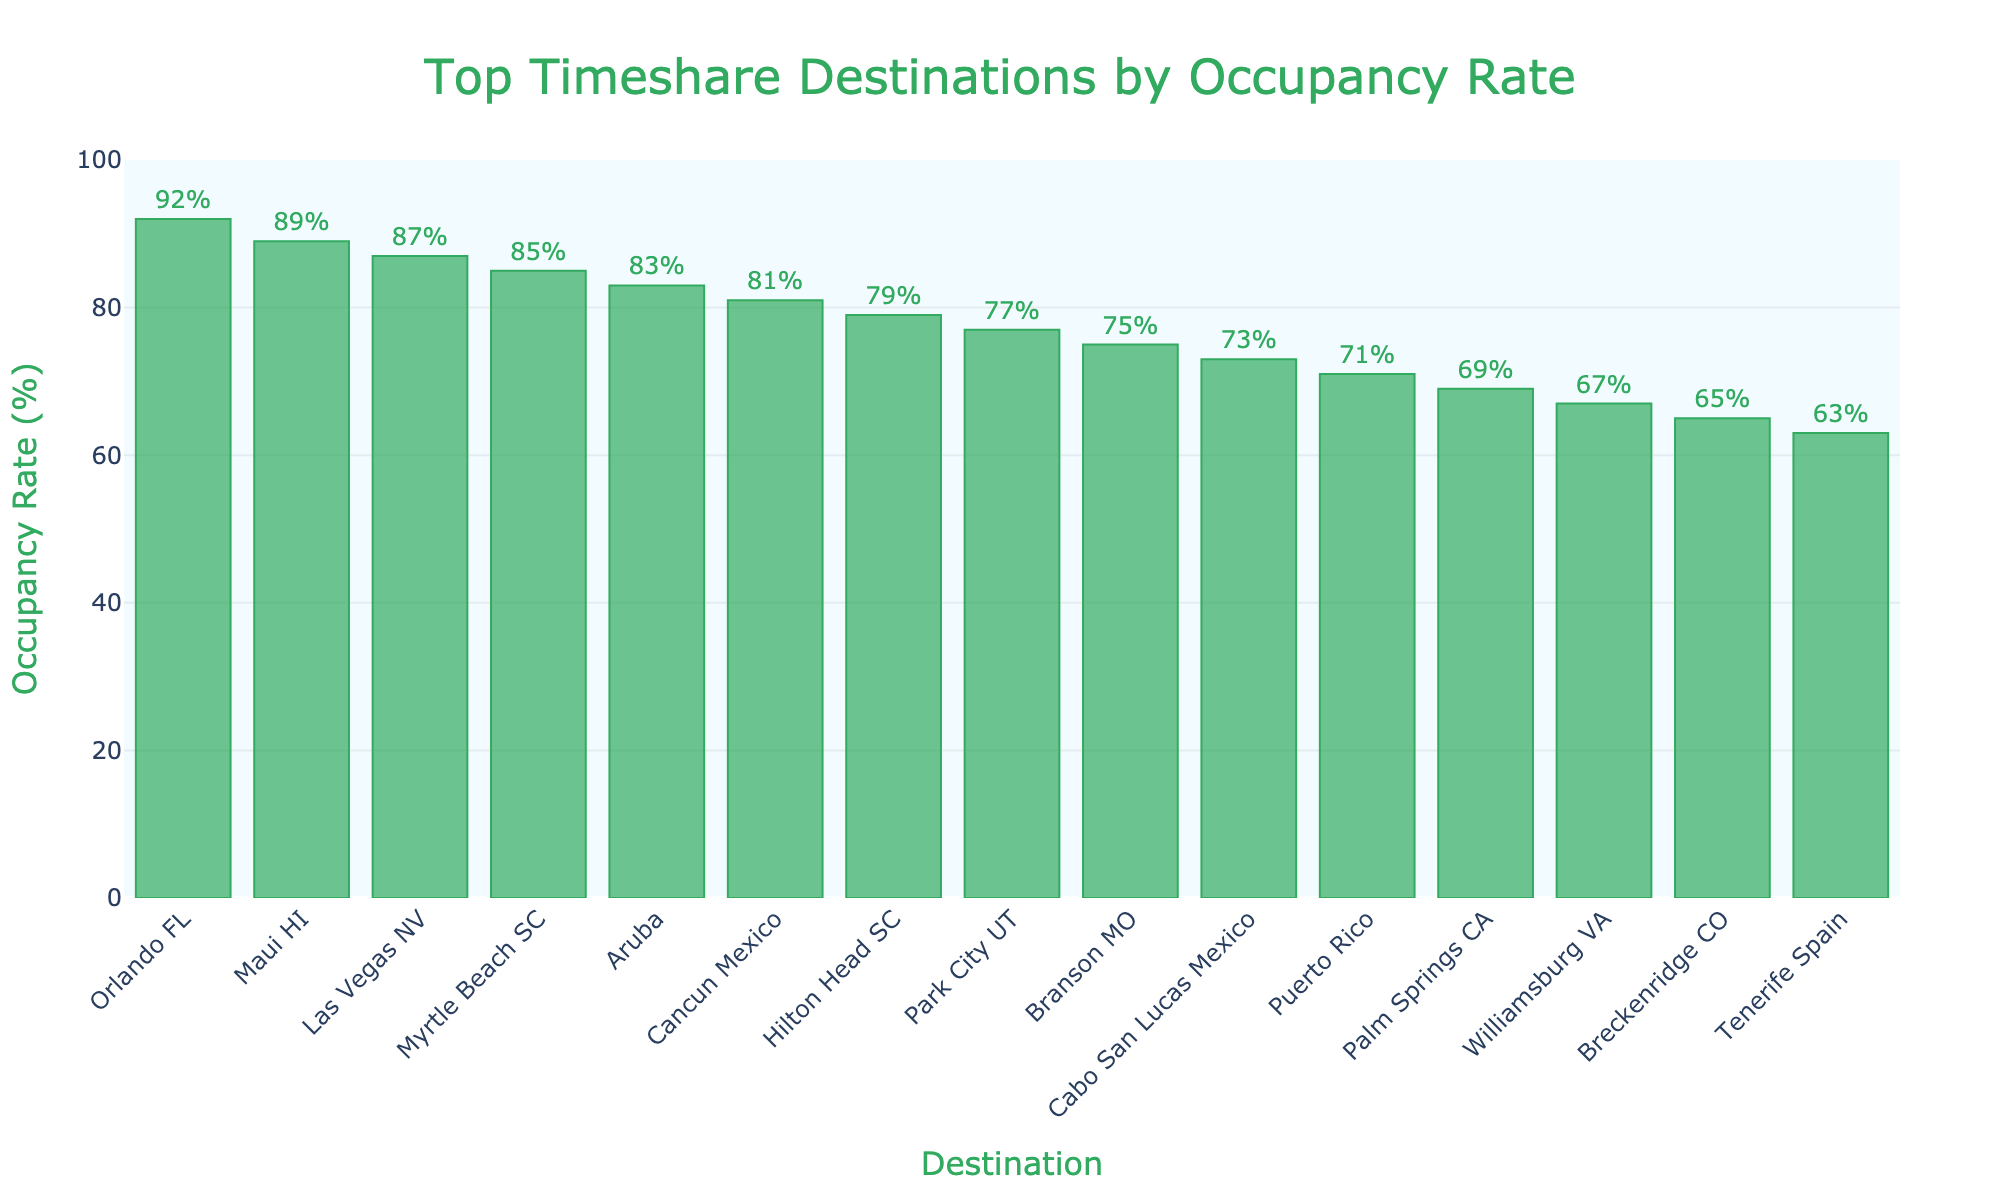which destination has the highest occupancy rate? The figure shows the destinations along with their occupancy rates in descending order. The first bar corresponds to the destination with the highest occupancy rate.
Answer: Orlando FL what is the difference in occupancy rate between Orlando FL and Cabo San Lucas Mexico? The occupancy rate for Orlando FL is 92%, and for Cabo San Lucas Mexico, it is 73%. The difference is calculated as 92% - 73%.
Answer: 19% how many destinations have an occupancy rate above 80%? By examining the bars in the figure, we count the number of destinations with occupancy rates above the 80% mark.
Answer: 6 which destination has a lower occupancy rate: Park City UT or Branson MO? By comparing the heights of the bars for Park City UT and Branson MO in the figure, we see that Park City UT has an occupancy rate of 77%, while Branson MO has 75%.
Answer: Branson MO what is the average occupancy rate of the top 5 destinations? The occupancy rates of the top 5 destinations are 92% (Orlando FL), 89% (Maui HI), 87% (Las Vegas NV), 85% (Myrtle Beach SC), and 83% (Aruba). Adding these and dividing by 5 gives the average: (92 + 89 + 87 + 85 + 83) / 5.
Answer: 87.2% which destinations have an occupancy rate exactly below 70%? From the figure, we look at the destinations with a bar height ending just below the 70% mark.
Answer: Puerto Rico, Palm Springs CA, Williamsburg VA, Breckenridge CO, Tenerife Spain how much higher is the occupancy rate of Maui HI compared to Puerto Rico? The occupancy rate for Maui HI is 89%, and for Puerto Rico, it is 71%. The difference is calculated as 89% - 71%.
Answer: 18% what is the range of occupancy rates among the top 10 destinations? The highest occupancy rate among the top 10 destinations is 92% (Orlando FL), and the lowest is 73% (Cabo San Lucas Mexico). The range is calculated as 92% - 73%.
Answer: 19% which destination has the second-highest occupancy rate and what is it? The second bar in the figure corresponds to the destination with the second-highest occupancy rate, which is Maui HI at 89%.
Answer: Maui HI, 89% which color is used for the bars in the chart? The visual appearance of the bars in the figure is described.
Answer: Green 